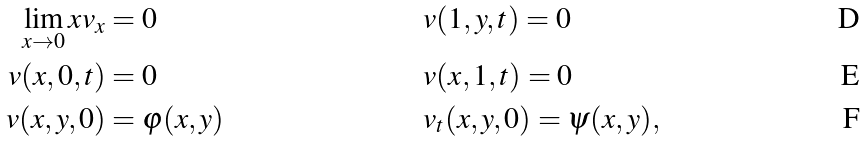<formula> <loc_0><loc_0><loc_500><loc_500>\lim _ { x \rightarrow 0 } x v _ { x } & = 0 & & v ( 1 , y , t ) = 0 \\ v ( x , 0 , t ) & = 0 & & v ( x , 1 , t ) = 0 \\ v ( x , y , 0 ) & = \varphi ( x , y ) & & v _ { t } ( x , y , 0 ) = \psi ( x , y ) ,</formula> 